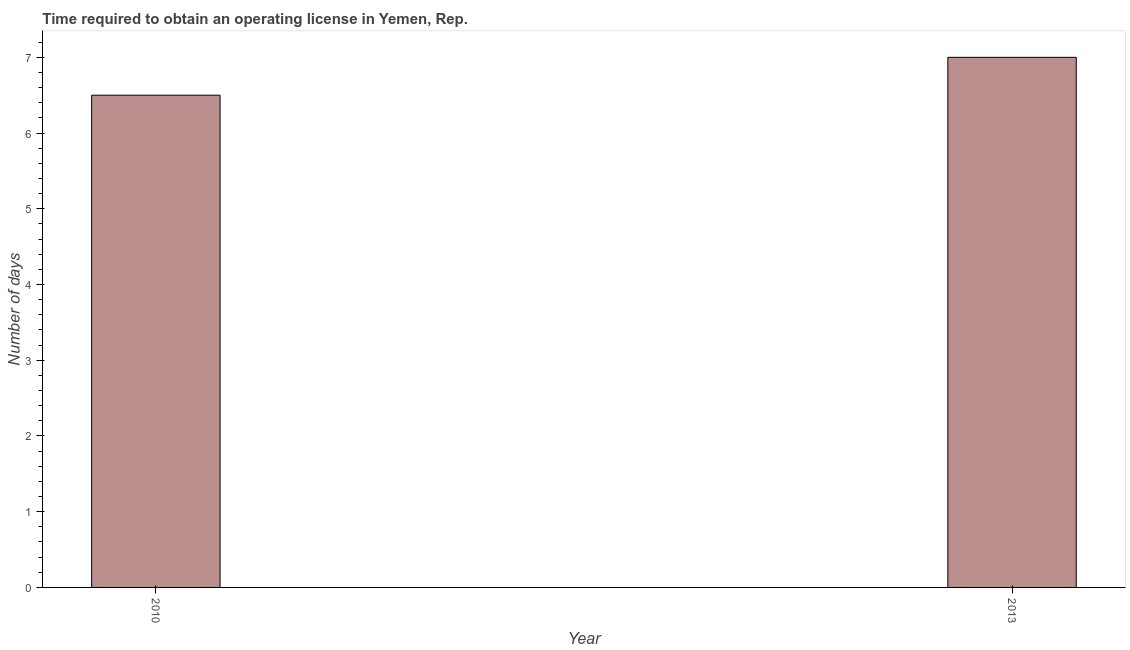What is the title of the graph?
Your answer should be very brief. Time required to obtain an operating license in Yemen, Rep. What is the label or title of the X-axis?
Your answer should be compact. Year. What is the label or title of the Y-axis?
Your answer should be very brief. Number of days. Across all years, what is the maximum number of days to obtain operating license?
Your response must be concise. 7. Across all years, what is the minimum number of days to obtain operating license?
Offer a terse response. 6.5. In which year was the number of days to obtain operating license minimum?
Provide a succinct answer. 2010. What is the sum of the number of days to obtain operating license?
Offer a very short reply. 13.5. What is the difference between the number of days to obtain operating license in 2010 and 2013?
Provide a short and direct response. -0.5. What is the average number of days to obtain operating license per year?
Give a very brief answer. 6.75. What is the median number of days to obtain operating license?
Provide a succinct answer. 6.75. In how many years, is the number of days to obtain operating license greater than 5.8 days?
Offer a terse response. 2. Do a majority of the years between 2010 and 2013 (inclusive) have number of days to obtain operating license greater than 5.6 days?
Ensure brevity in your answer.  Yes. What is the ratio of the number of days to obtain operating license in 2010 to that in 2013?
Provide a succinct answer. 0.93. Is the number of days to obtain operating license in 2010 less than that in 2013?
Your answer should be compact. Yes. How many bars are there?
Keep it short and to the point. 2. Are all the bars in the graph horizontal?
Ensure brevity in your answer.  No. How many years are there in the graph?
Your answer should be compact. 2. Are the values on the major ticks of Y-axis written in scientific E-notation?
Make the answer very short. No. What is the Number of days of 2013?
Provide a succinct answer. 7. What is the difference between the Number of days in 2010 and 2013?
Keep it short and to the point. -0.5. What is the ratio of the Number of days in 2010 to that in 2013?
Provide a short and direct response. 0.93. 